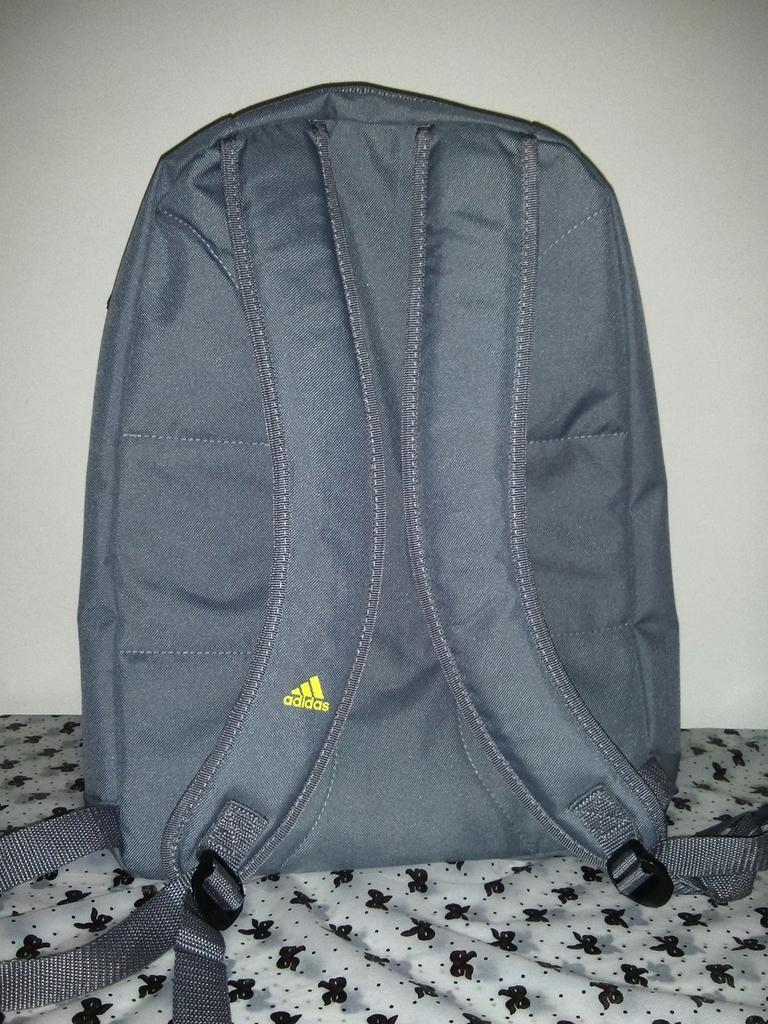<image>
Create a compact narrative representing the image presented. A grey adidias backpack on fabric covered in balck ribbons 